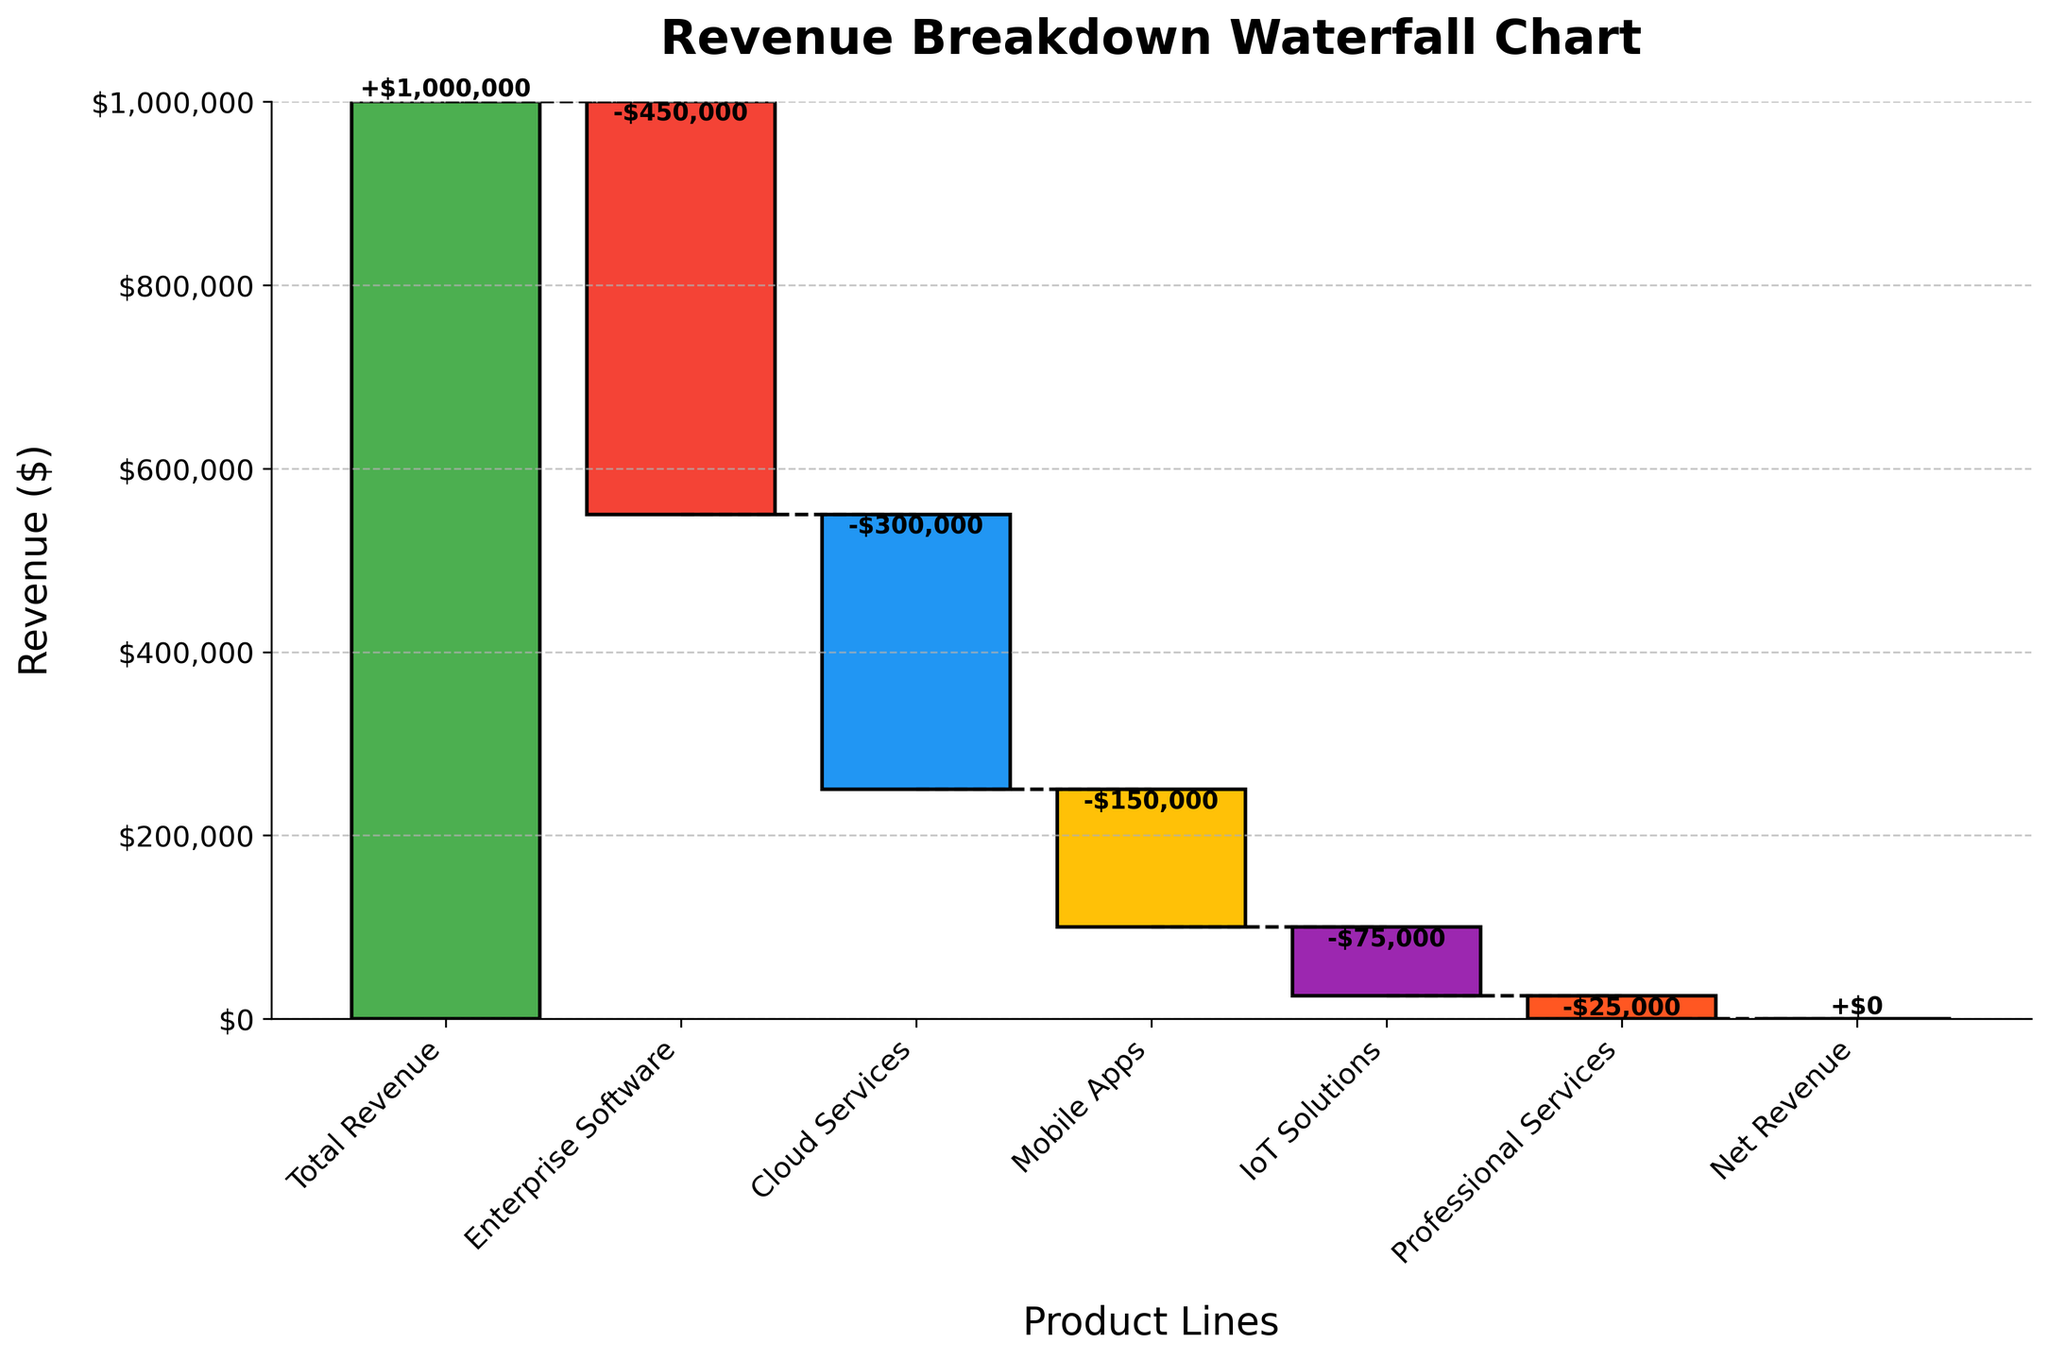What is the title of the chart? The title can be found at the top of the chart, and it is usually used to describe the main subject of the figure.
Answer: Revenue Breakdown Waterfall Chart Which product line has the highest negative revenue? Looking at the chart, the product line with the longest bar extending downwards indicates the highest negative revenue.
Answer: Enterprise Software What is the total revenue shown in the chart? The total revenue is shown as the first bar in the waterfall chart, usually representing the starting value.
Answer: $1,000,000 What is the cumulative revenue after accounting for Enterprise Software and Cloud Services? First, add the negative revenue of Enterprise Software (-450,000) to the total revenue (1,000,000) to get 550,000. Then, add the negative revenue of Cloud Services (-300,000) to 550,000 to get 250,000.
Answer: $250,000 How does the revenue from Professional Services compare to that from IoT Solutions? IoT Solutions has a negative revenue of $75,000, while Professional Services has a negative revenue of $25,000. Comparing these values shows that IoT Solutions has a higher negative impact.
Answer: IoT Solutions has higher negative revenue What are the labels listed on the x-axis of the chart? The x-axis labels can be found at the bottom of the chart and indicate the different product lines contributing to the total revenue.
Answer: Total Revenue, Enterprise Software, Cloud Services, Mobile Apps, IoT Solutions, Professional Services, Net Revenue Which product line has the least negative impact on revenue? On the chart, the product line with the shortest downward bar indicates the least negative impact on revenue.
Answer: Professional Services What is the revenue of the Mobile Apps product line? The Mobile Apps bar on the waterfall chart shows the negative revenue contribution from this product line.
Answer: -$150,000 What is the net revenue after all contributions? Net revenue is usually the final bar in a waterfall chart, representing the result of adding up all contributions. Since all the product lines have negative contributions, and the final cumulative sum is zero, the net revenue is correctly zero.
Answer: $0 How much does the Cloud Services revenue decrease the total revenue by? The Cloud Services bar in the waterfall chart shows its negative impact on the total revenue.
Answer: $300,000 